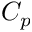<formula> <loc_0><loc_0><loc_500><loc_500>C _ { p }</formula> 